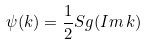<formula> <loc_0><loc_0><loc_500><loc_500>\psi ( k ) = \frac { 1 } { 2 } S g ( I m \, k )</formula> 